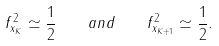<formula> <loc_0><loc_0><loc_500><loc_500>f _ { x _ { K } } ^ { 2 } \simeq \frac { 1 } { 2 } \quad a n d \quad f _ { x _ { K + 1 } } ^ { 2 } \simeq \frac { 1 } { 2 } .</formula> 